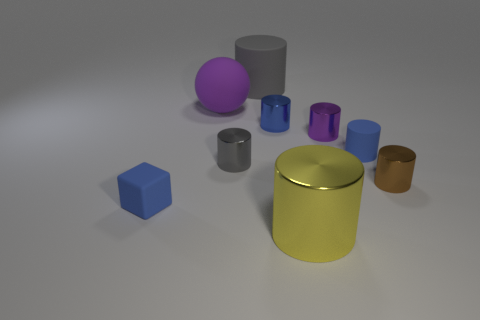Subtract all tiny metallic cylinders. How many cylinders are left? 3 Subtract all cyan balls. How many gray cylinders are left? 2 Subtract 1 blocks. How many blocks are left? 0 Subtract all blue cylinders. How many cylinders are left? 5 Subtract all cylinders. How many objects are left? 2 Subtract all gray cylinders. Subtract all green cubes. How many cylinders are left? 5 Subtract all small balls. Subtract all rubber balls. How many objects are left? 8 Add 6 purple things. How many purple things are left? 8 Add 1 small brown objects. How many small brown objects exist? 2 Subtract 0 green spheres. How many objects are left? 9 